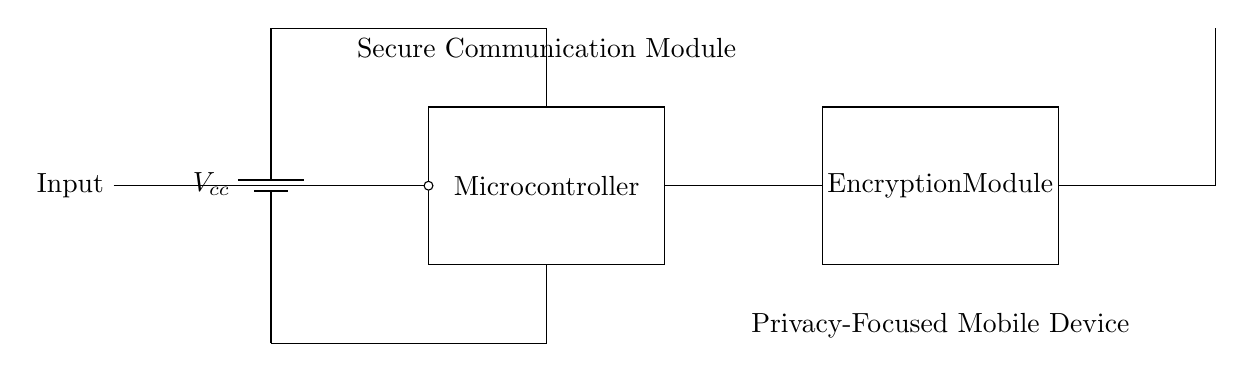What is the power supply type in this circuit? The circuit uses a battery as the power supply, indicated by the component labeled 'battery1'.
Answer: battery What components are included in the secure communication module? The main components are a microcontroller and an encryption module, shown in rectangles.
Answer: microcontroller, encryption module How many main functional blocks are present in the circuit? There are three main functional blocks: the microcontroller, the encryption module, and the antenna.
Answer: three What is the role of the antenna in this circuit? The antenna is used for wireless communication, as indicated by its function and position in the circuit.
Answer: wireless communication What connects the microcontroller to the encryption module? The connection is a line that directly links the microcontroller to the encryption module.
Answer: line What voltage is applied to the circuit? The circuit uses a voltage denoted by Vcc, which is typically the supply voltage. The specific value isn't shown in the diagram.
Answer: Vcc 